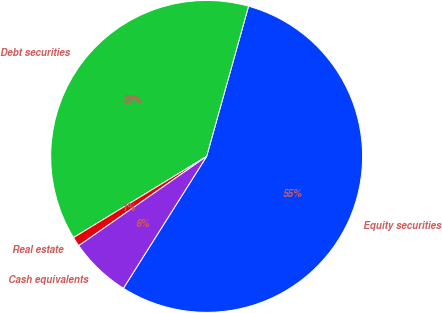Convert chart to OTSL. <chart><loc_0><loc_0><loc_500><loc_500><pie_chart><fcel>Equity securities<fcel>Debt securities<fcel>Real estate<fcel>Cash equivalents<nl><fcel>54.63%<fcel>38.05%<fcel>0.98%<fcel>6.34%<nl></chart> 